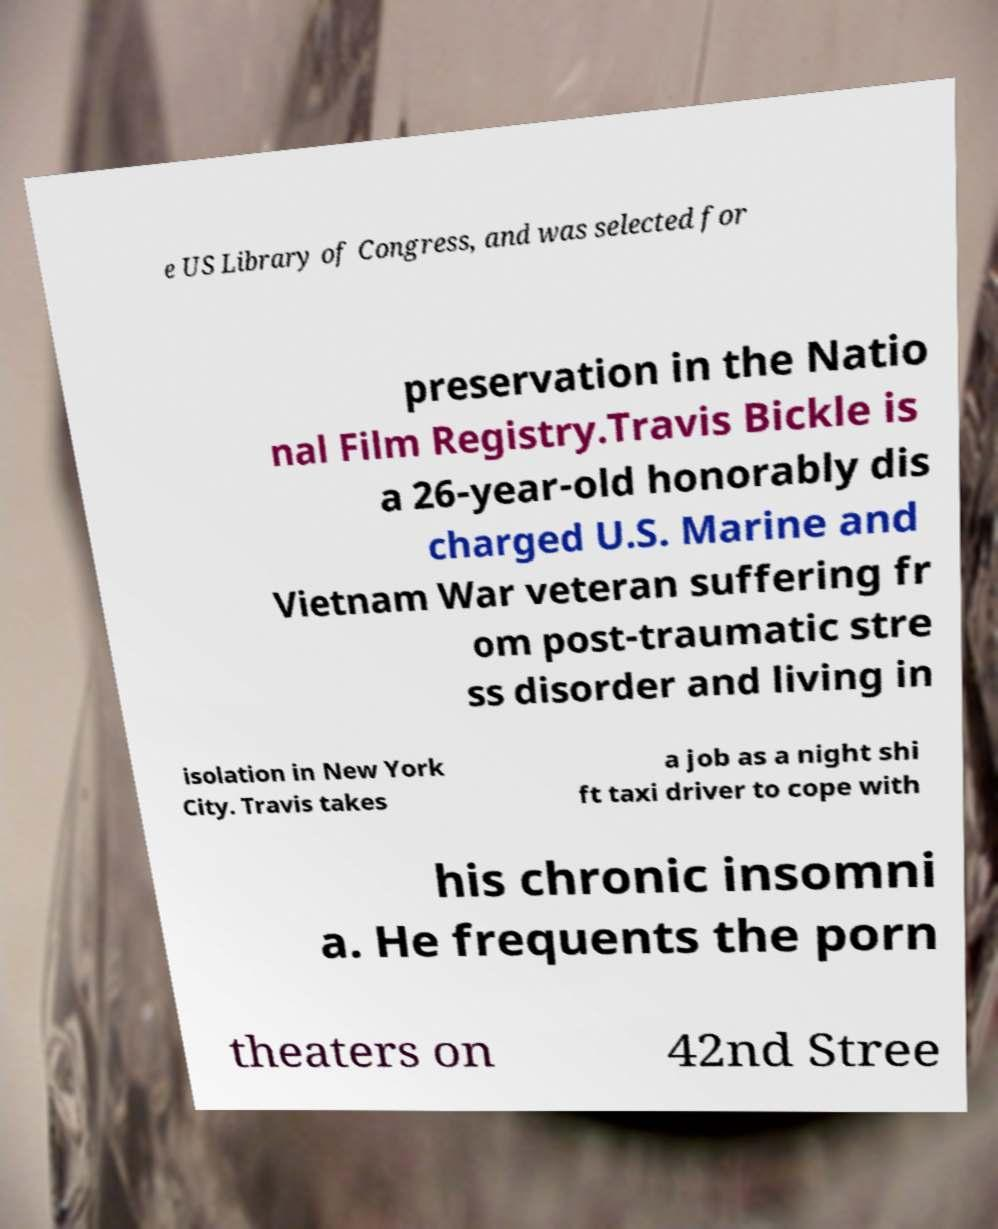What messages or text are displayed in this image? I need them in a readable, typed format. e US Library of Congress, and was selected for preservation in the Natio nal Film Registry.Travis Bickle is a 26-year-old honorably dis charged U.S. Marine and Vietnam War veteran suffering fr om post-traumatic stre ss disorder and living in isolation in New York City. Travis takes a job as a night shi ft taxi driver to cope with his chronic insomni a. He frequents the porn theaters on 42nd Stree 